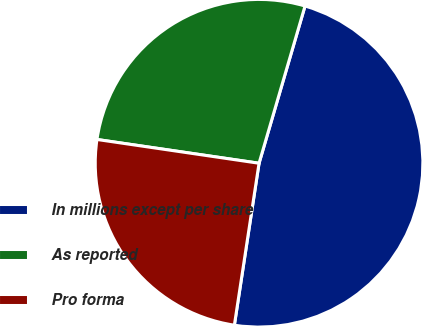Convert chart to OTSL. <chart><loc_0><loc_0><loc_500><loc_500><pie_chart><fcel>In millions except per share<fcel>As reported<fcel>Pro forma<nl><fcel>47.88%<fcel>27.21%<fcel>24.91%<nl></chart> 